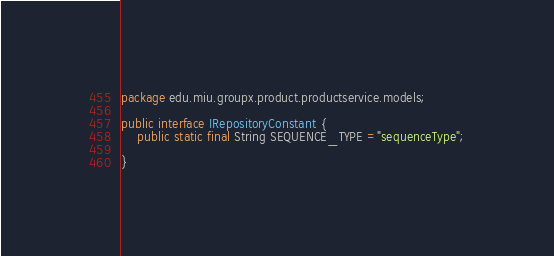<code> <loc_0><loc_0><loc_500><loc_500><_Java_>package edu.miu.groupx.product.productservice.models;

public interface IRepositoryConstant {
    public static final String SEQUENCE_TYPE ="sequenceType";

}
</code> 